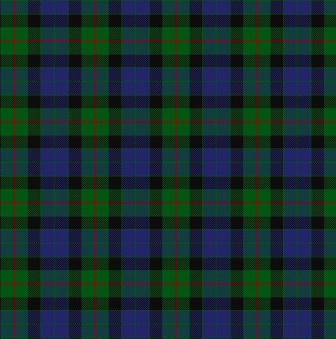How would this pattern be used in a modern clothing design? In modern clothing design, this tartan pattern could be used to create stylish and versatile pieces such as scarves, skirts, jackets, and even accessories like handbags and ties. The design's timeless appeal and structured pattern can be adapted to both traditional and contemporary styles, making it suitable for various fashion statements. By incorporating this classic tartan into modern outfits, designers can blend heritage and modern aesthetics, appealing to a wide range of fashion-conscious individuals. Can this pattern be used to design a distinct modern outfit? Absolutely! Imagine a chic, modern outfit that combines the elegance of this classic tartan pattern with contemporary cuts and fabrics. Envision a tailored tartan blazer paired with slim-fit black trousers and a crisp white shirt, creating a sharp and professional look. Alternatively, a tartan-patterned high-waisted skirt with a black turtleneck and ankle boots would deliver a sophisticated yet stylish ensemble. Accessories like a tartan infinity scarf or a crossbody bag can elevate a casual outfit, adding a touch of traditional flair to everyday wear. The versatility of this tartan pattern allows it to seamlessly blend into modern fashion while making a distinct statement. 